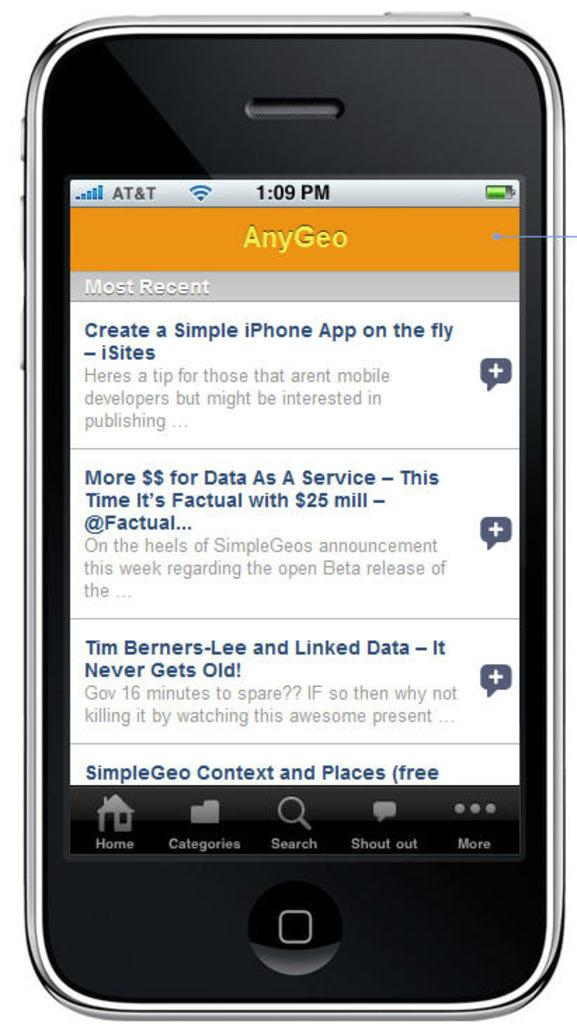<image>
Create a compact narrative representing the image presented. A smart phone with AT&T service has several search results on the screen under the heading AnyGeo. 